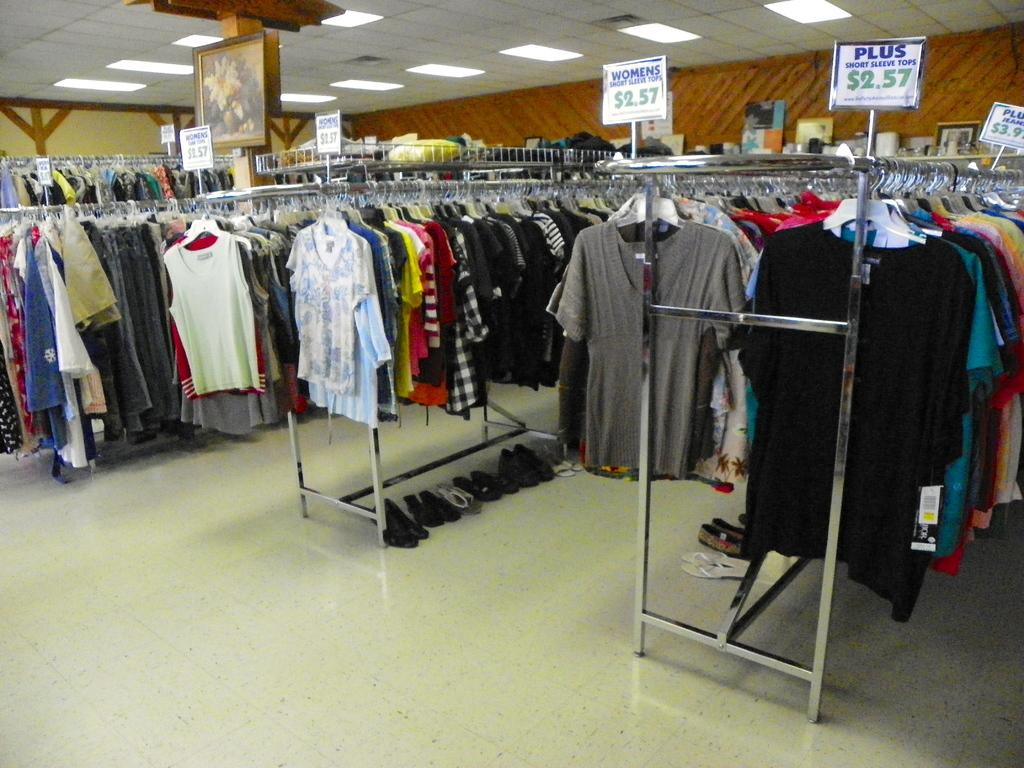<image>
Give a short and clear explanation of the subsequent image. Several racks of clothes are arranged with the sign reading PLUS written in blue on the right side. 